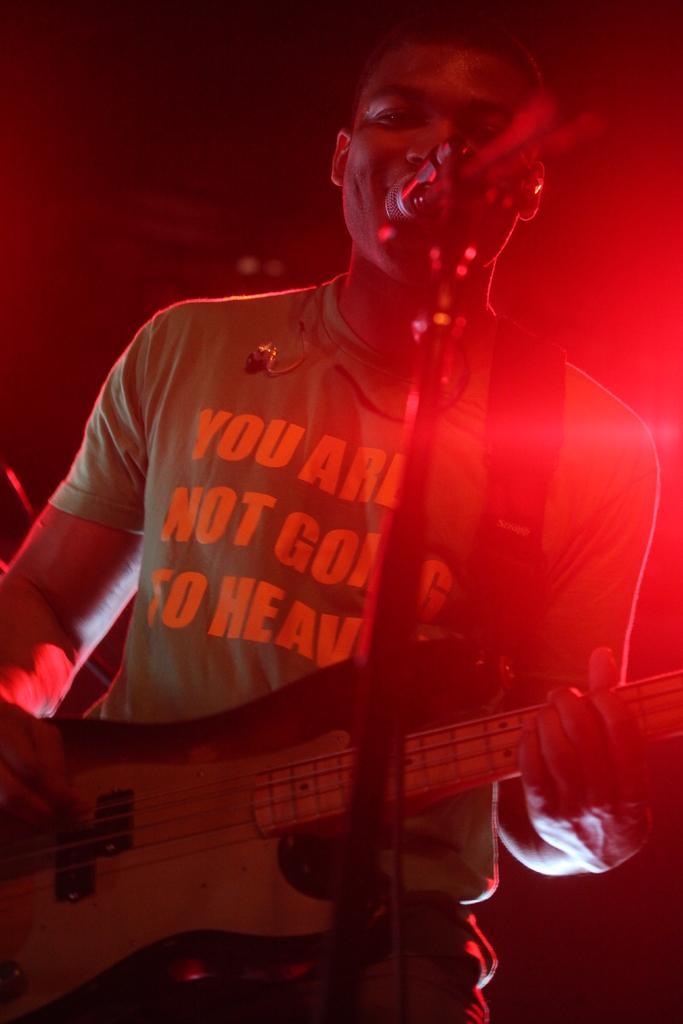In one or two sentences, can you explain what this image depicts? In this picture, we can see a person holding musical instrument, we can see microphone with pole, red light, and the dark background. 